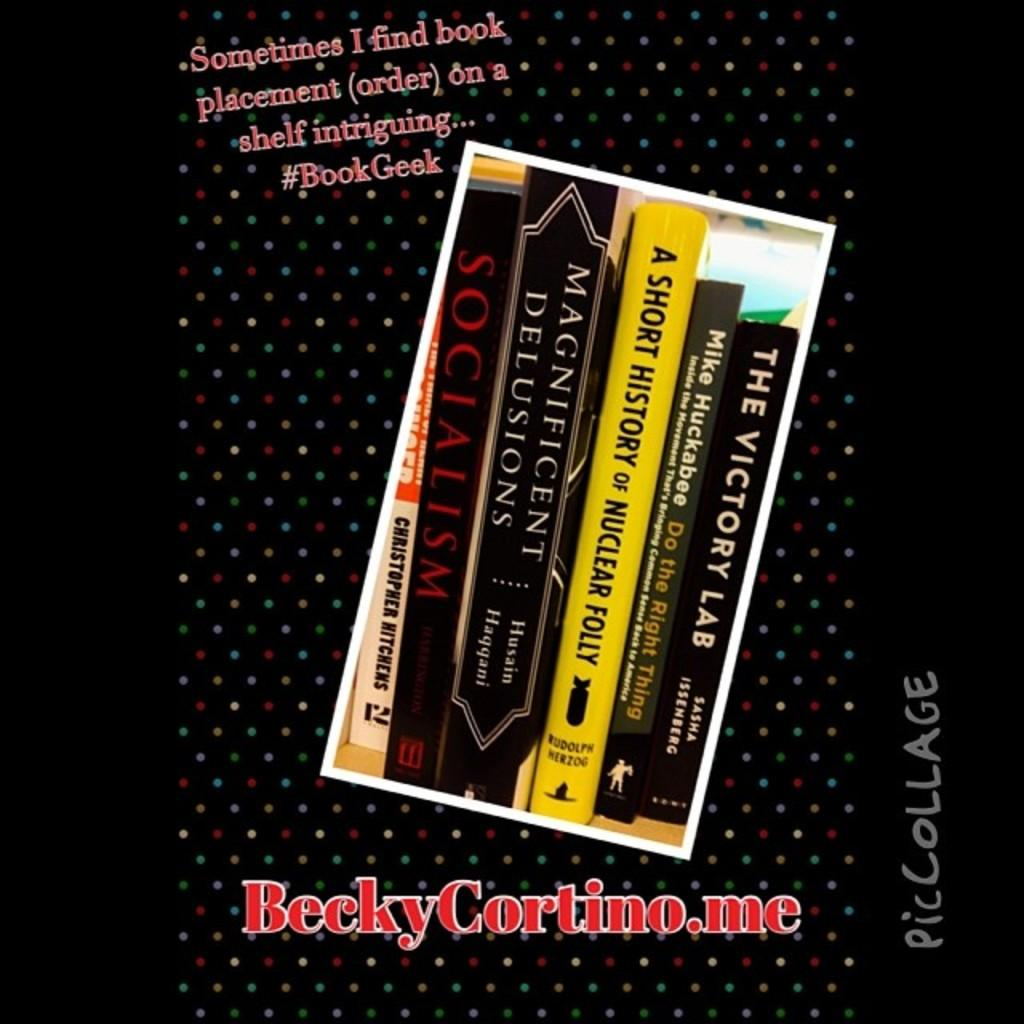<image>
Offer a succinct explanation of the picture presented. Pic Collage with book titles on a black background and #BookGeek 